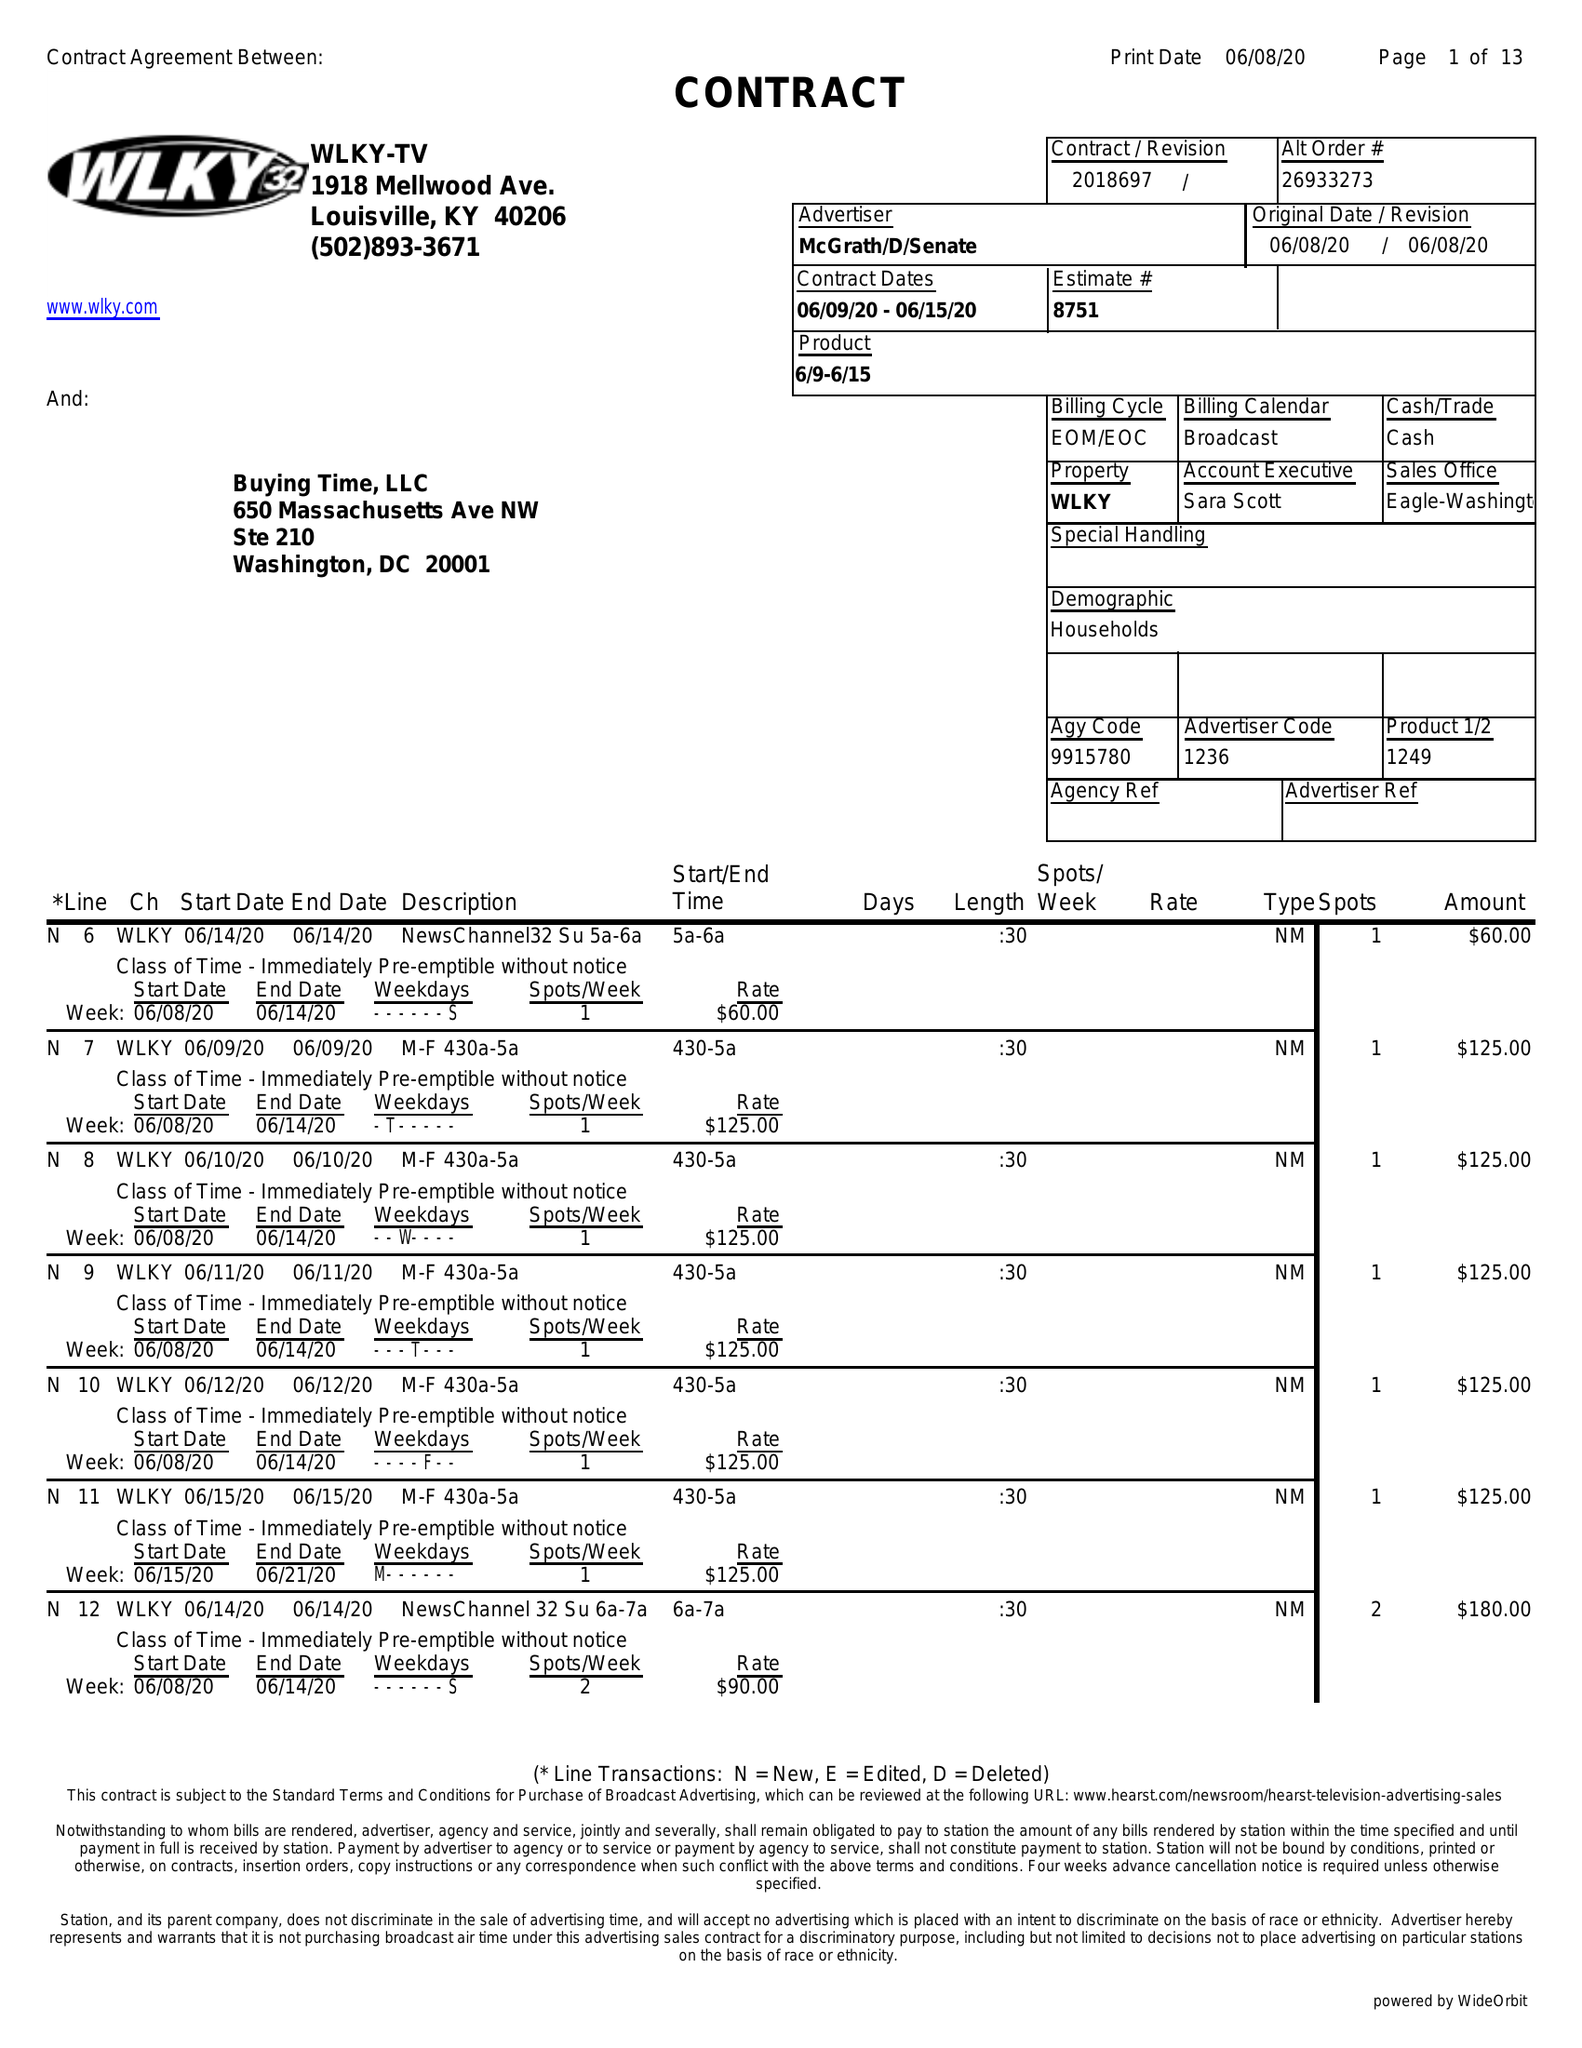What is the value for the flight_to?
Answer the question using a single word or phrase. 06/15/20 